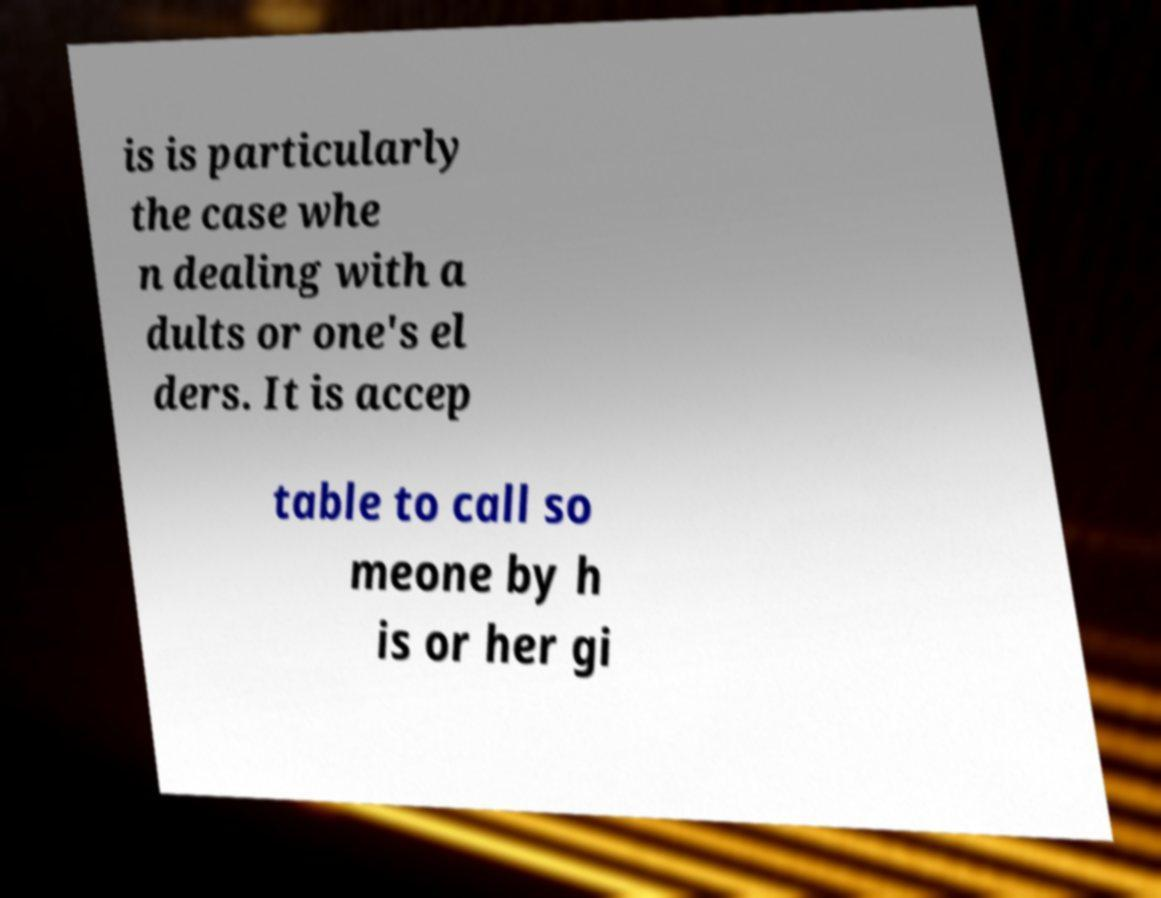Please read and relay the text visible in this image. What does it say? is is particularly the case whe n dealing with a dults or one's el ders. It is accep table to call so meone by h is or her gi 